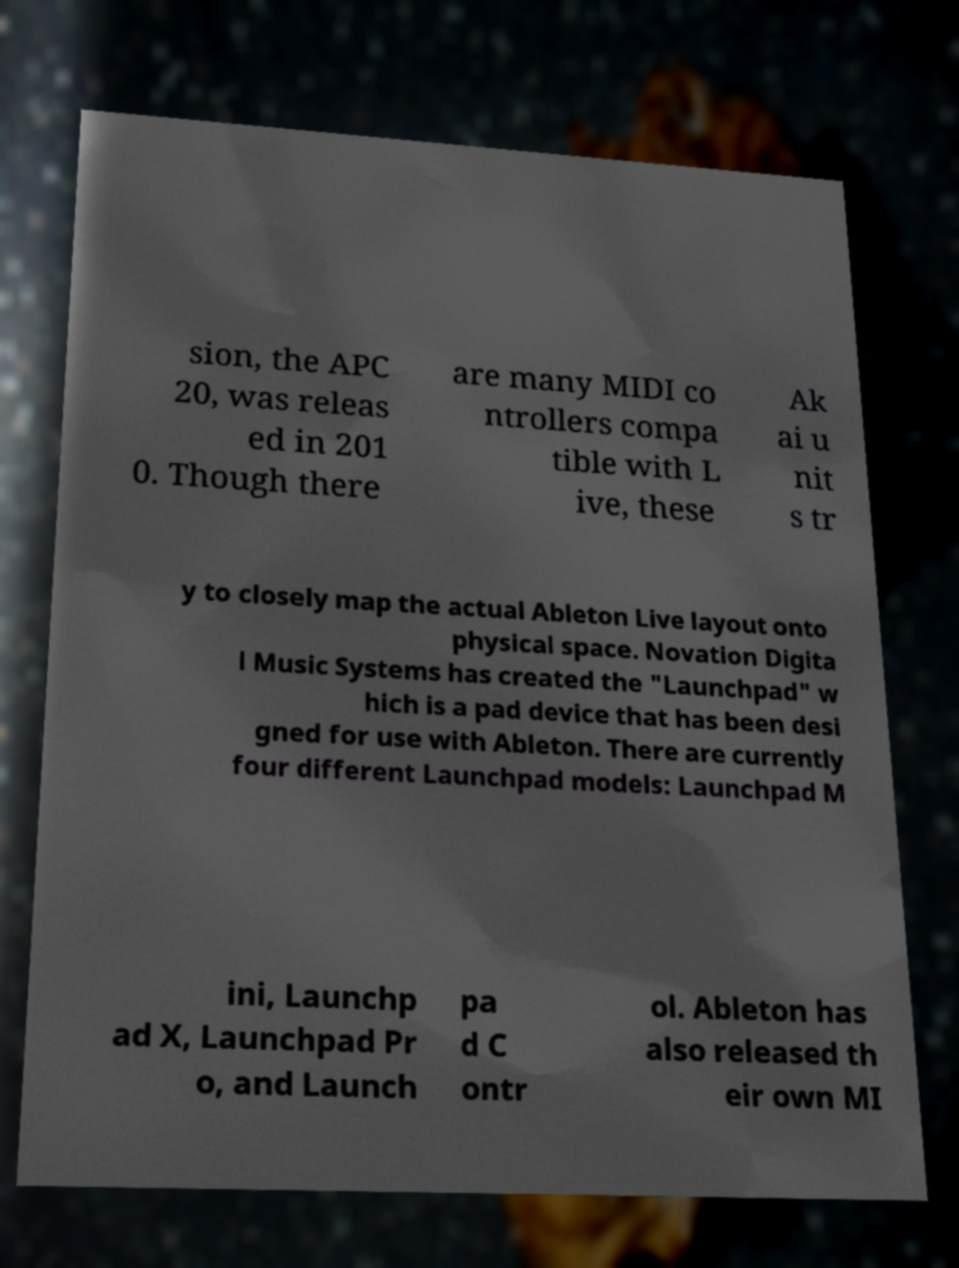There's text embedded in this image that I need extracted. Can you transcribe it verbatim? sion, the APC 20, was releas ed in 201 0. Though there are many MIDI co ntrollers compa tible with L ive, these Ak ai u nit s tr y to closely map the actual Ableton Live layout onto physical space. Novation Digita l Music Systems has created the "Launchpad" w hich is a pad device that has been desi gned for use with Ableton. There are currently four different Launchpad models: Launchpad M ini, Launchp ad X, Launchpad Pr o, and Launch pa d C ontr ol. Ableton has also released th eir own MI 